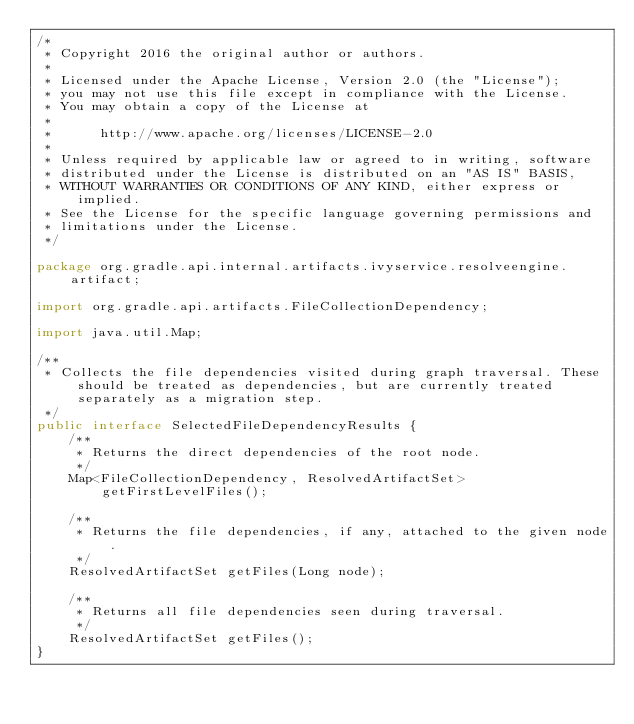Convert code to text. <code><loc_0><loc_0><loc_500><loc_500><_Java_>/*
 * Copyright 2016 the original author or authors.
 *
 * Licensed under the Apache License, Version 2.0 (the "License");
 * you may not use this file except in compliance with the License.
 * You may obtain a copy of the License at
 *
 *      http://www.apache.org/licenses/LICENSE-2.0
 *
 * Unless required by applicable law or agreed to in writing, software
 * distributed under the License is distributed on an "AS IS" BASIS,
 * WITHOUT WARRANTIES OR CONDITIONS OF ANY KIND, either express or implied.
 * See the License for the specific language governing permissions and
 * limitations under the License.
 */

package org.gradle.api.internal.artifacts.ivyservice.resolveengine.artifact;

import org.gradle.api.artifacts.FileCollectionDependency;

import java.util.Map;

/**
 * Collects the file dependencies visited during graph traversal. These should be treated as dependencies, but are currently treated separately as a migration step.
 */
public interface SelectedFileDependencyResults {
    /**
     * Returns the direct dependencies of the root node.
     */
    Map<FileCollectionDependency, ResolvedArtifactSet> getFirstLevelFiles();

    /**
     * Returns the file dependencies, if any, attached to the given node.
     */
    ResolvedArtifactSet getFiles(Long node);

    /**
     * Returns all file dependencies seen during traversal.
     */
    ResolvedArtifactSet getFiles();
}
</code> 